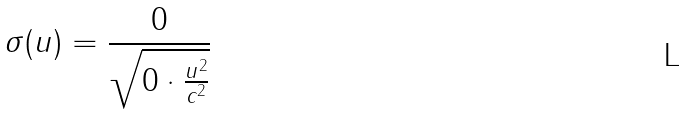<formula> <loc_0><loc_0><loc_500><loc_500>\sigma ( u ) = \frac { 0 } { \sqrt { 0 \cdot \frac { u ^ { 2 } } { c ^ { 2 } } } }</formula> 